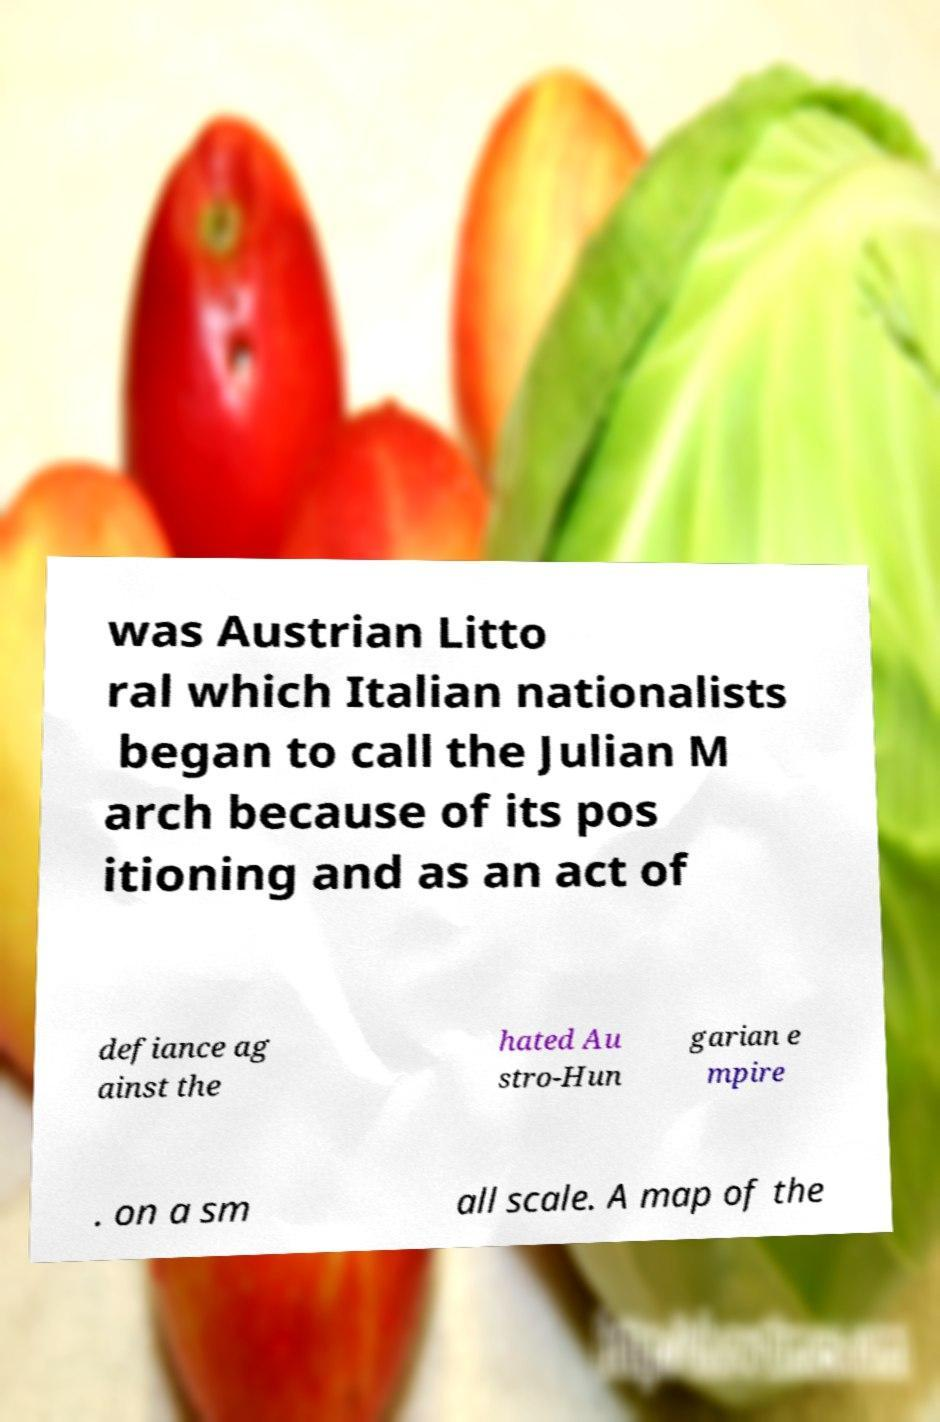Please read and relay the text visible in this image. What does it say? was Austrian Litto ral which Italian nationalists began to call the Julian M arch because of its pos itioning and as an act of defiance ag ainst the hated Au stro-Hun garian e mpire . on a sm all scale. A map of the 